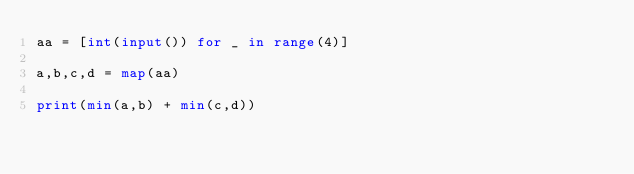<code> <loc_0><loc_0><loc_500><loc_500><_Python_>aa = [int(input()) for _ in range(4)]

a,b,c,d = map(aa)

print(min(a,b) + min(c,d))</code> 